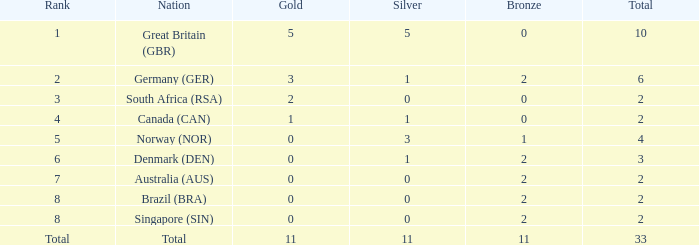What is bronze when the rank is 3 and the total is more than 2? None. 